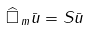Convert formula to latex. <formula><loc_0><loc_0><loc_500><loc_500>\widehat { \Box } _ { \, m } \bar { u } = S \bar { u }</formula> 